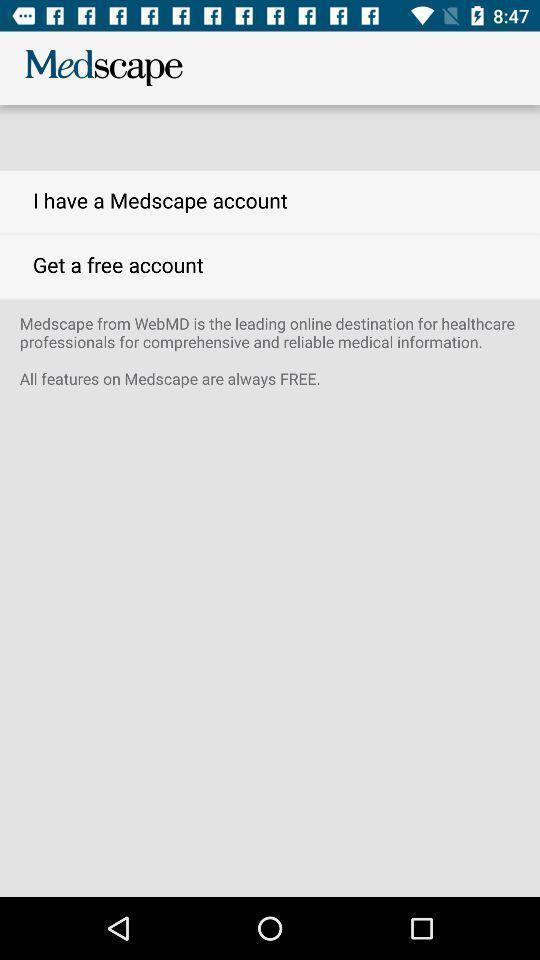Summarize the information in this screenshot. Page with options for a medical app. 